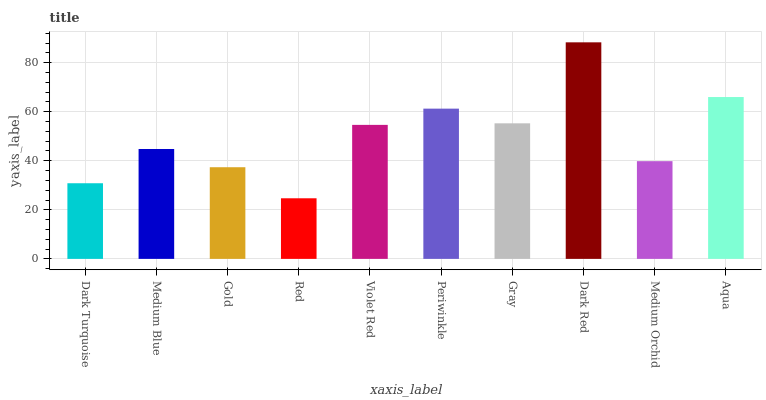Is Red the minimum?
Answer yes or no. Yes. Is Dark Red the maximum?
Answer yes or no. Yes. Is Medium Blue the minimum?
Answer yes or no. No. Is Medium Blue the maximum?
Answer yes or no. No. Is Medium Blue greater than Dark Turquoise?
Answer yes or no. Yes. Is Dark Turquoise less than Medium Blue?
Answer yes or no. Yes. Is Dark Turquoise greater than Medium Blue?
Answer yes or no. No. Is Medium Blue less than Dark Turquoise?
Answer yes or no. No. Is Violet Red the high median?
Answer yes or no. Yes. Is Medium Blue the low median?
Answer yes or no. Yes. Is Red the high median?
Answer yes or no. No. Is Dark Red the low median?
Answer yes or no. No. 